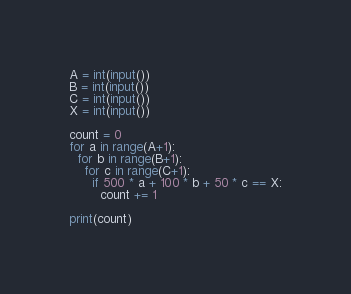Convert code to text. <code><loc_0><loc_0><loc_500><loc_500><_Python_>A = int(input())
B = int(input())
C = int(input())
X = int(input())

count = 0
for a in range(A+1):
  for b in range(B+1):
    for c in range(C+1):
      if 500 * a + 100 * b + 50 * c == X:
        count += 1

print(count)
</code> 